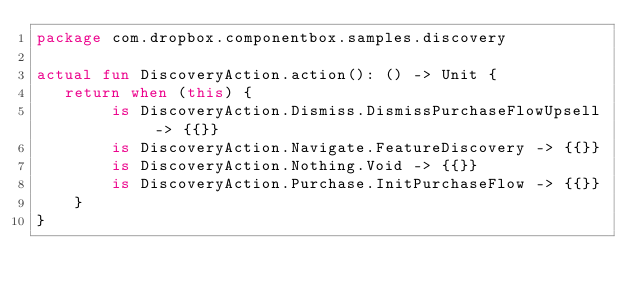<code> <loc_0><loc_0><loc_500><loc_500><_Kotlin_>package com.dropbox.componentbox.samples.discovery

actual fun DiscoveryAction.action(): () -> Unit {
   return when (this) {
        is DiscoveryAction.Dismiss.DismissPurchaseFlowUpsell -> {{}}
        is DiscoveryAction.Navigate.FeatureDiscovery -> {{}}
        is DiscoveryAction.Nothing.Void -> {{}}
        is DiscoveryAction.Purchase.InitPurchaseFlow -> {{}}
    }
}</code> 